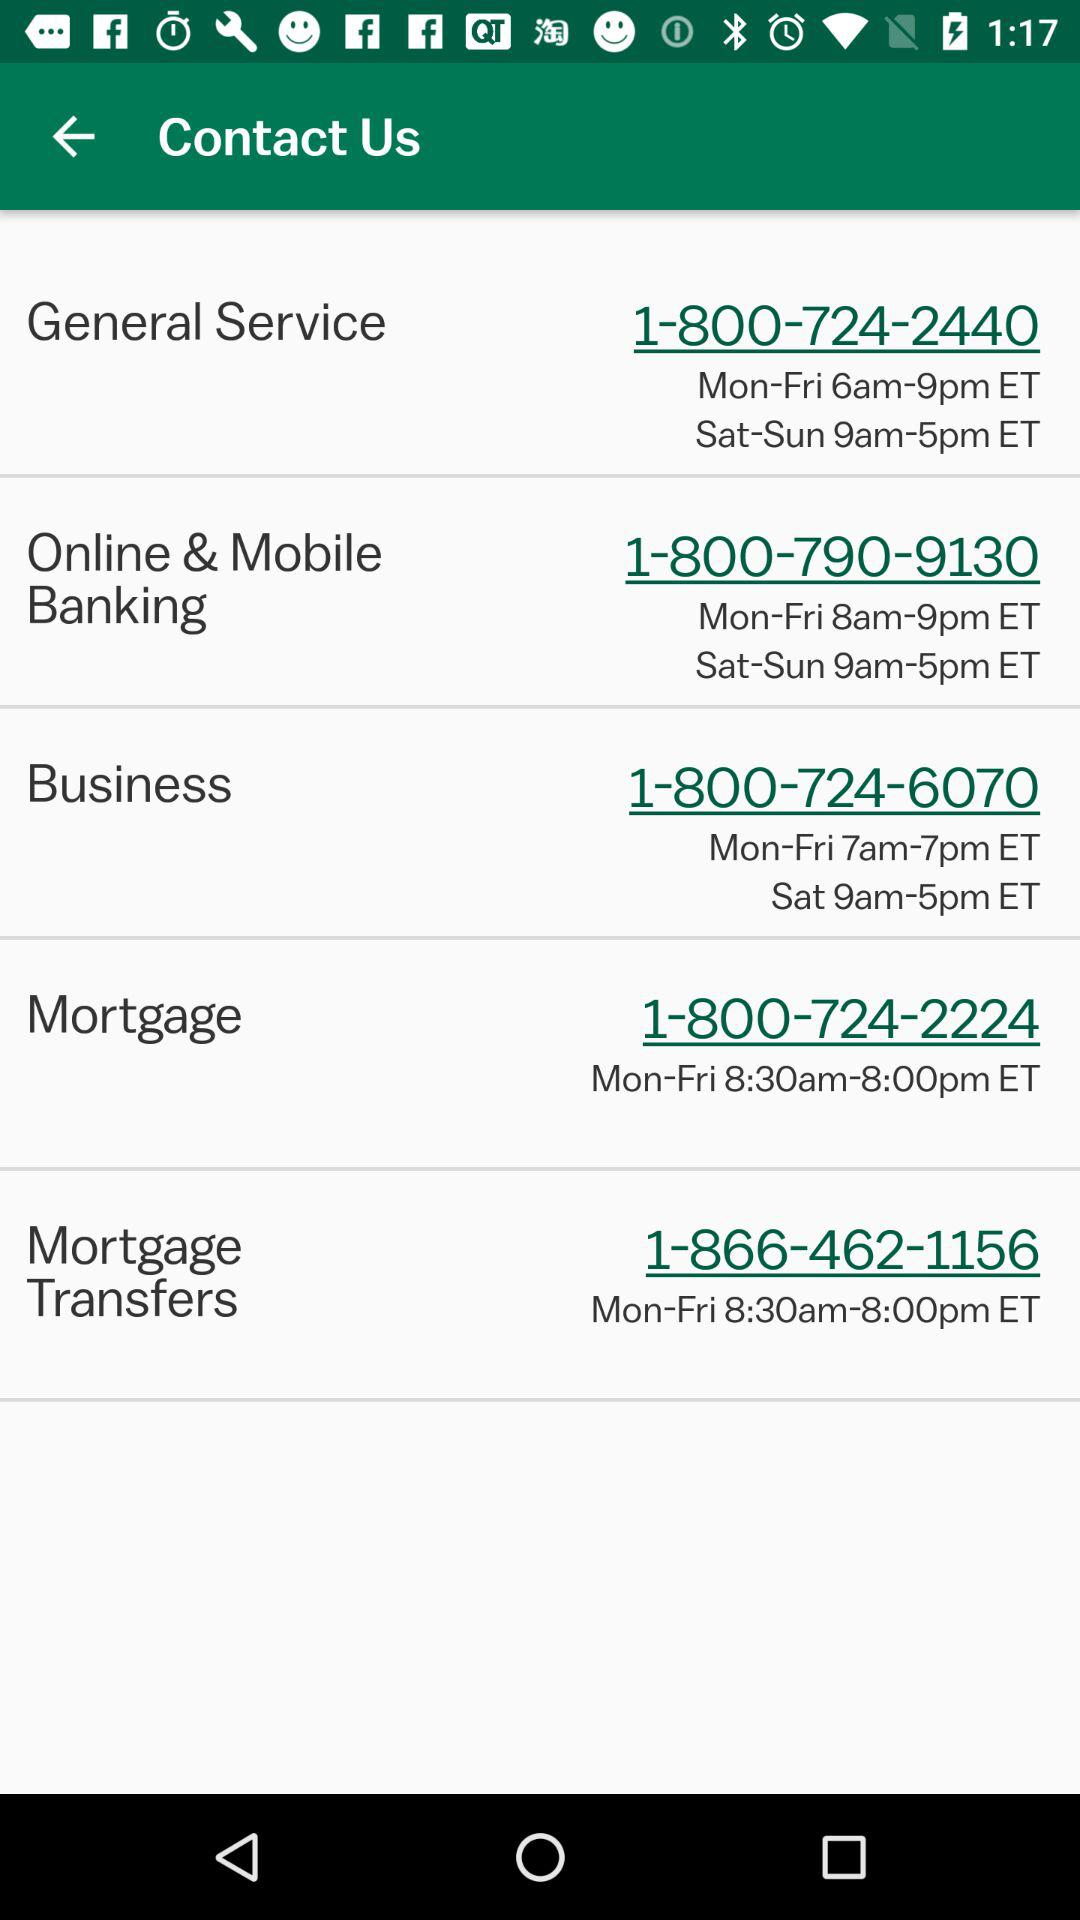What is the phone number to contact for general service? The phone number is 18007242440. 